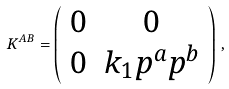Convert formula to latex. <formula><loc_0><loc_0><loc_500><loc_500>K ^ { A B } = \left ( \begin{array} { c c } 0 & 0 \\ 0 & k _ { 1 } p ^ { a } p ^ { b } \end{array} \right ) \, ,</formula> 